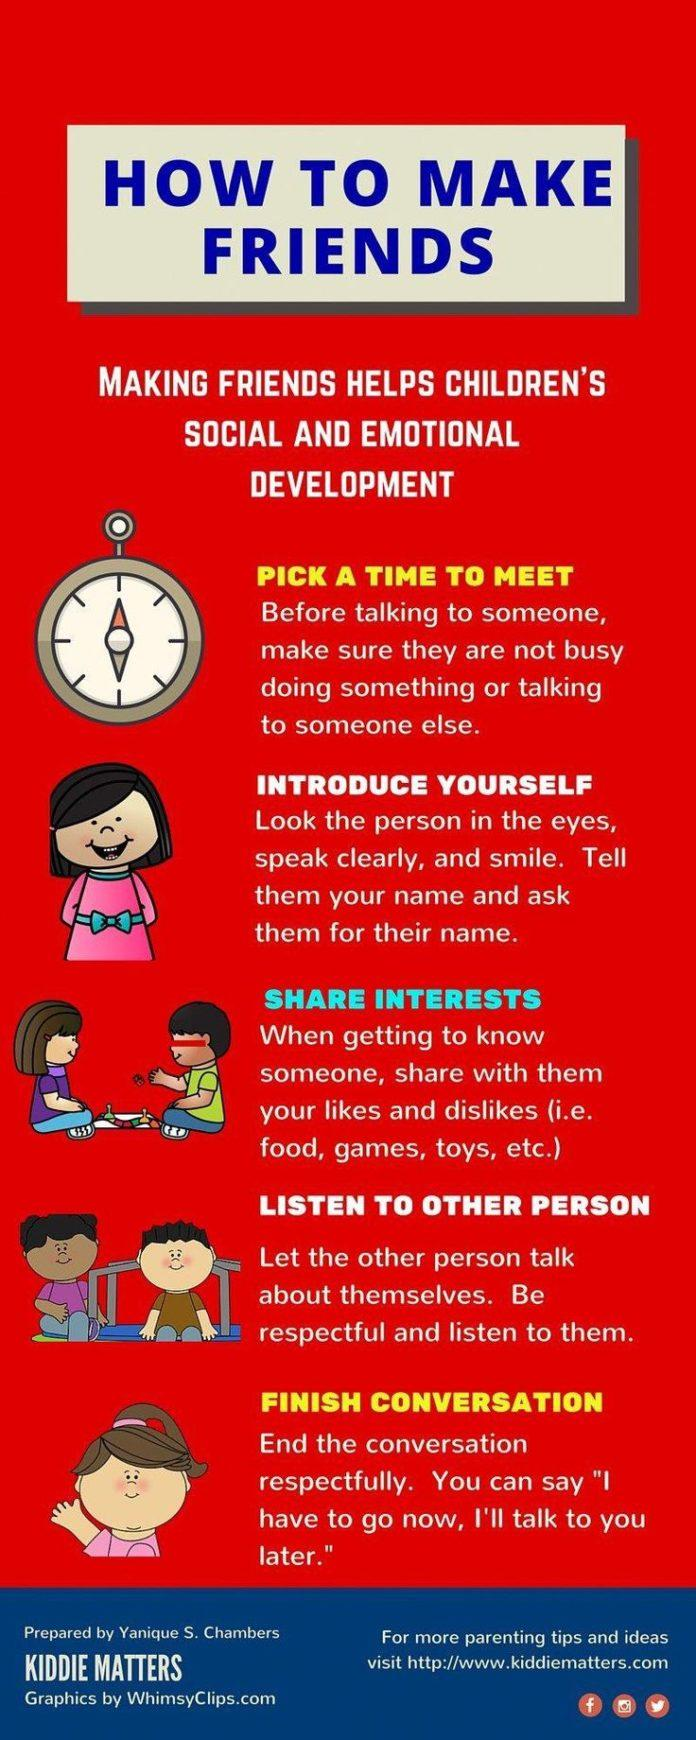Give some essential details in this illustration. There are five points under the heading of 'How to make friends?' The second point under the heading of "How to make friends" is "Introduce Yourself. There are four girls depicted in this infographic. There are two boys depicted in this infographic. 